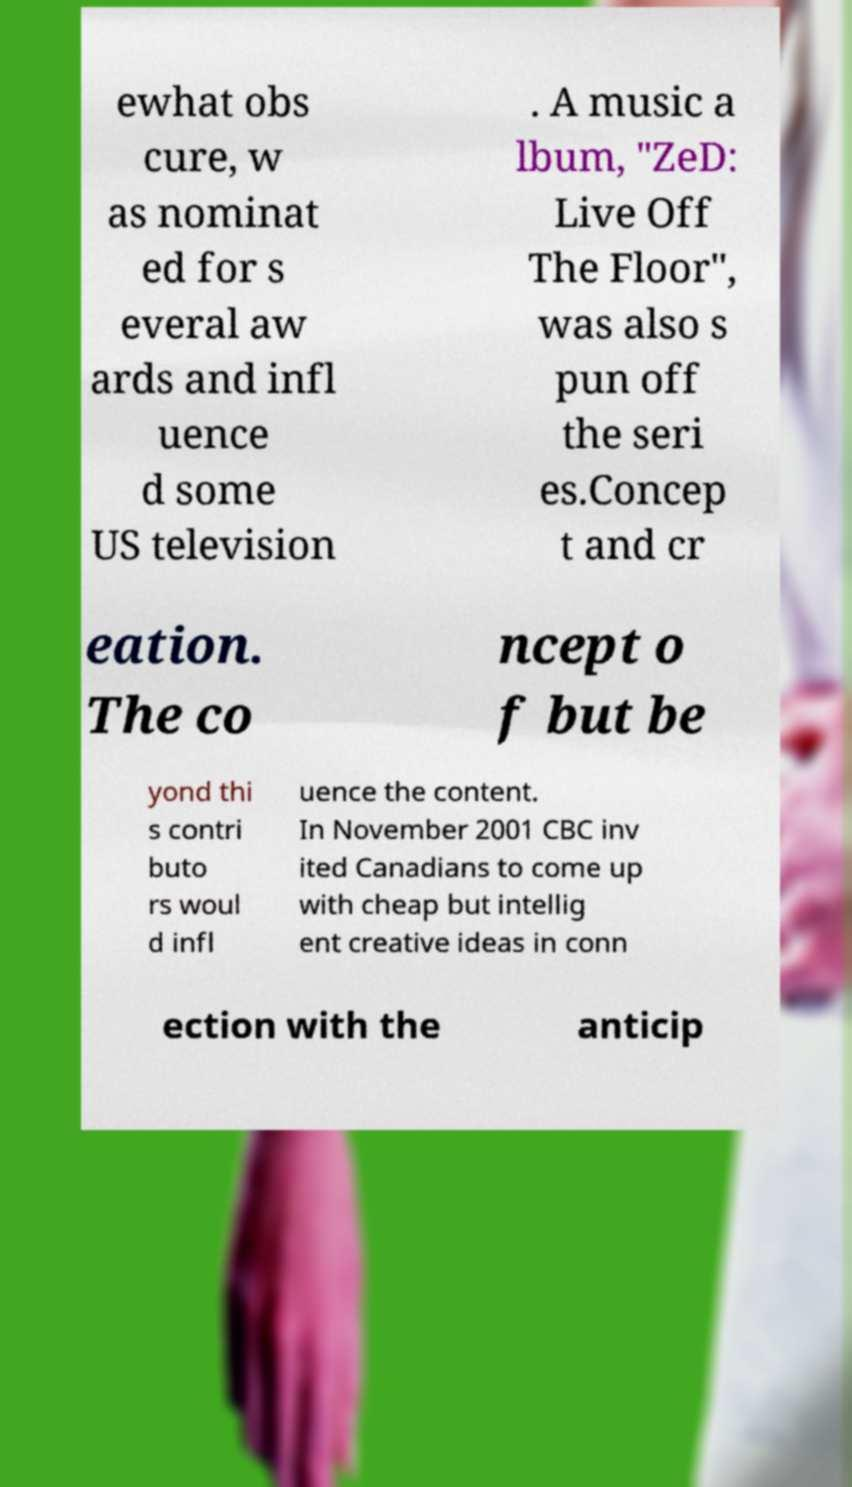What messages or text are displayed in this image? I need them in a readable, typed format. ewhat obs cure, w as nominat ed for s everal aw ards and infl uence d some US television . A music a lbum, "ZeD: Live Off The Floor", was also s pun off the seri es.Concep t and cr eation. The co ncept o f but be yond thi s contri buto rs woul d infl uence the content. In November 2001 CBC inv ited Canadians to come up with cheap but intellig ent creative ideas in conn ection with the anticip 